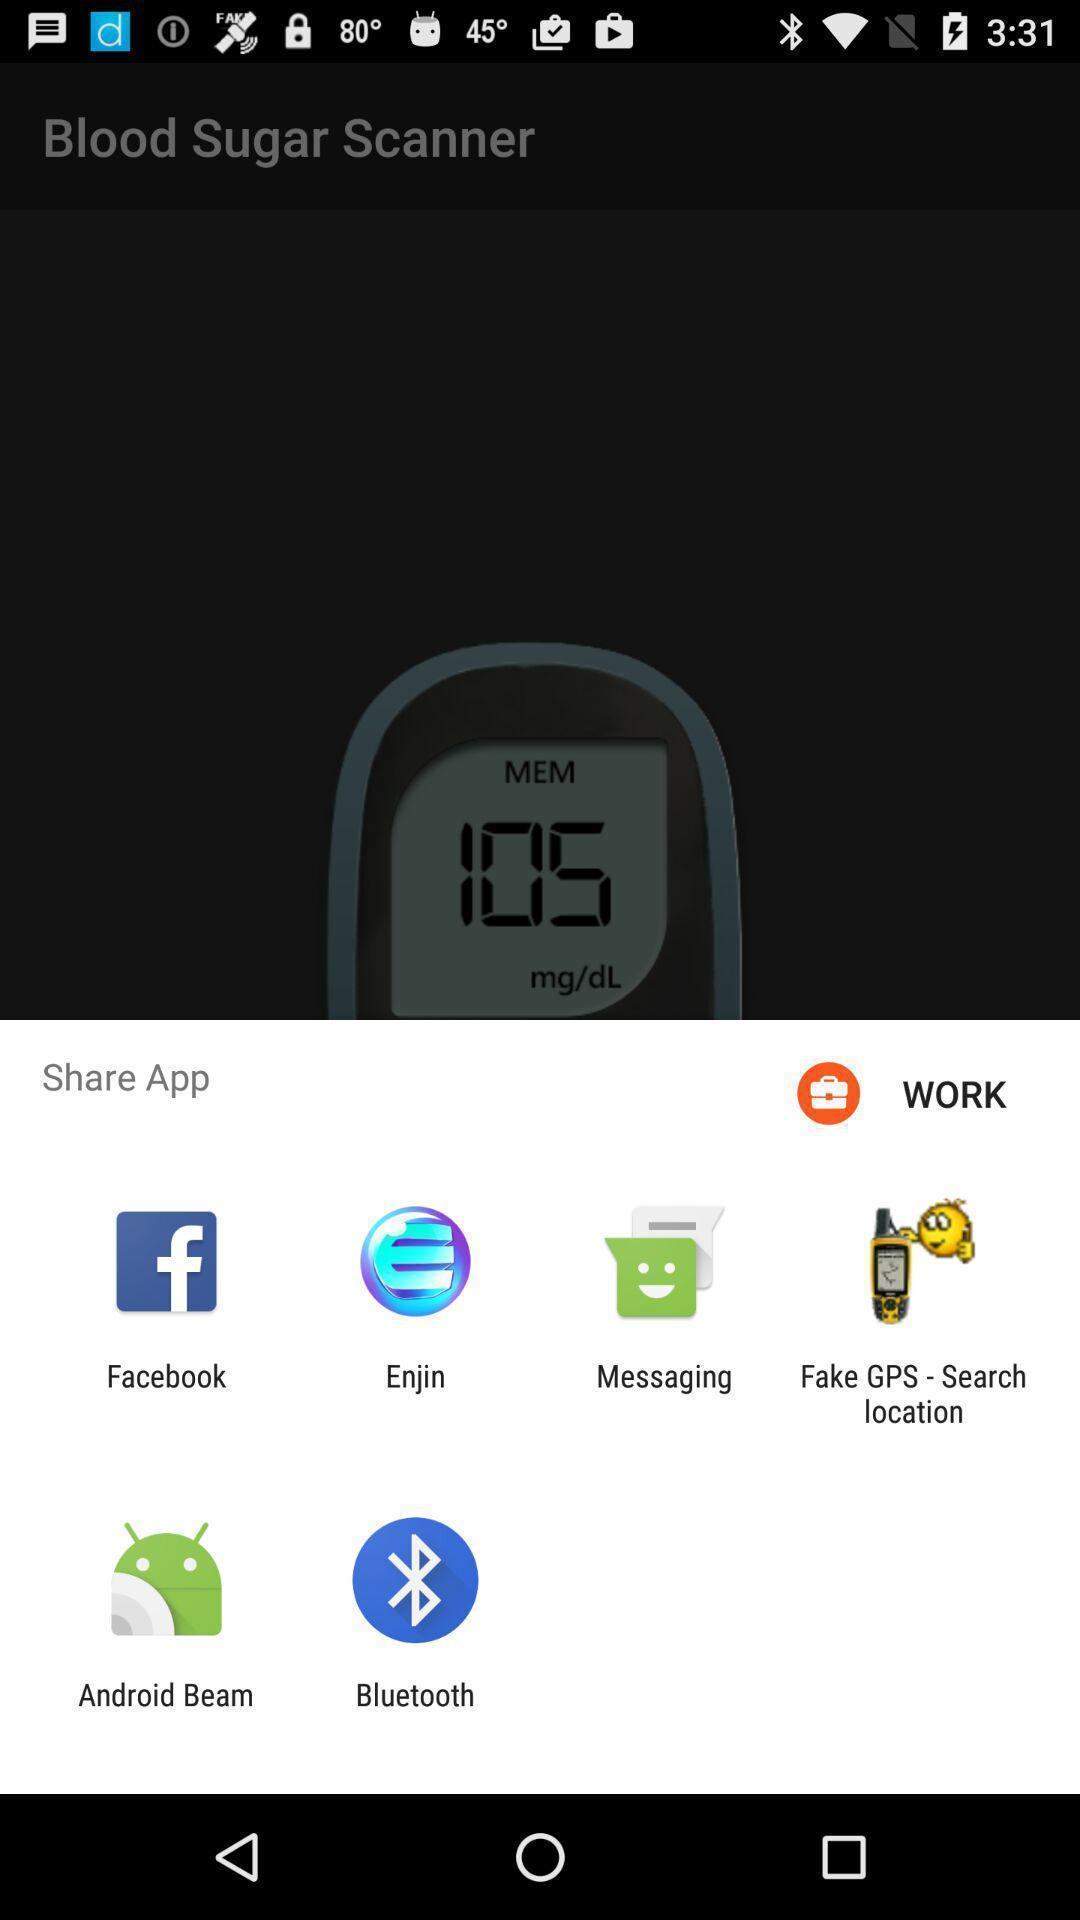Describe the content in this image. Push up message for sharing data via social network. 